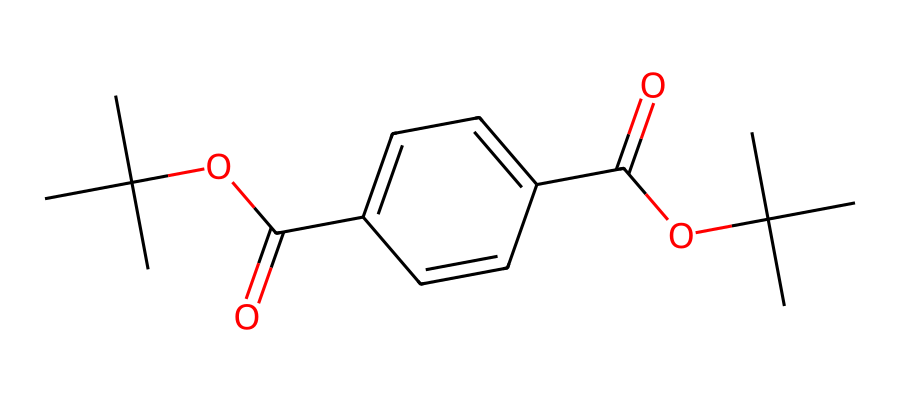What is the core functional group present in this chemical? The chemical structure contains ester groups, which are characterized by the presence of a carbonyl (C=O) adjacent to an ether linkage (C-O). This is evident in the OC(=O) part of the SMILES representation.
Answer: ester How many carbon atoms are in this molecule? By analyzing the SMILES notation, we can count the carbon atoms represented. The notation CC(C)(C) indicates three carbons in a branching structure, and additional carbon atoms can be counted throughout the rest of the molecule, totaling 15 carbon atoms.
Answer: 15 What type of bonds are primarily found in this chemical structure? The molecule primarily contains covalent bonds, which are the bonds formed between carbon and oxygen atoms within the structure. Covalent bonds are typical in organic compounds, including plastics.
Answer: covalent bonds What is the significance of the branching in this chemical? The branching in the chemical structure, indicated by CC(C)(C), affects the physical properties of the plastic, such as flexibility and clarity. Branching often leads to lower densities and modifies the way the material behaves under stress.
Answer: flexibility How many ester groups does this chemical contain? The molecule contains two ester groups, evident from the two occurrences of the OC(=O) structure within the SMILES, indicating two points where olate connects to carbonyl.
Answer: 2 